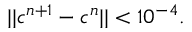<formula> <loc_0><loc_0><loc_500><loc_500>| | c ^ { n + 1 } - c ^ { n } | | < 1 0 ^ { - 4 } .</formula> 